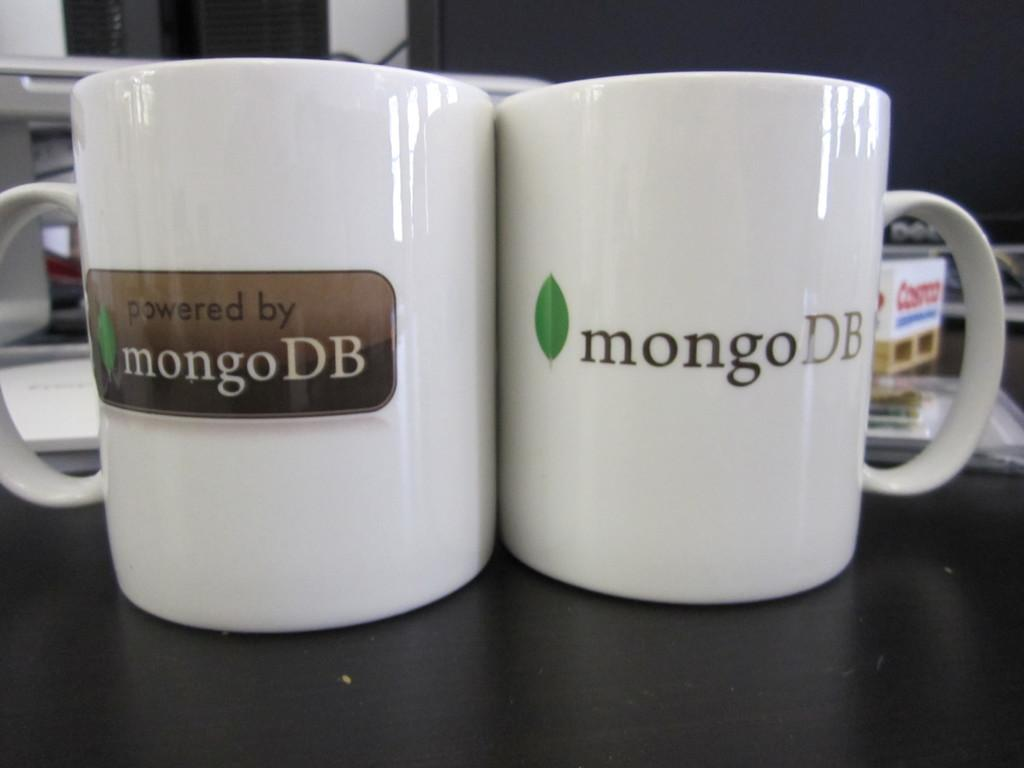Provide a one-sentence caption for the provided image. Two white coffee cups emblazoned with the logo for mongoDB. 